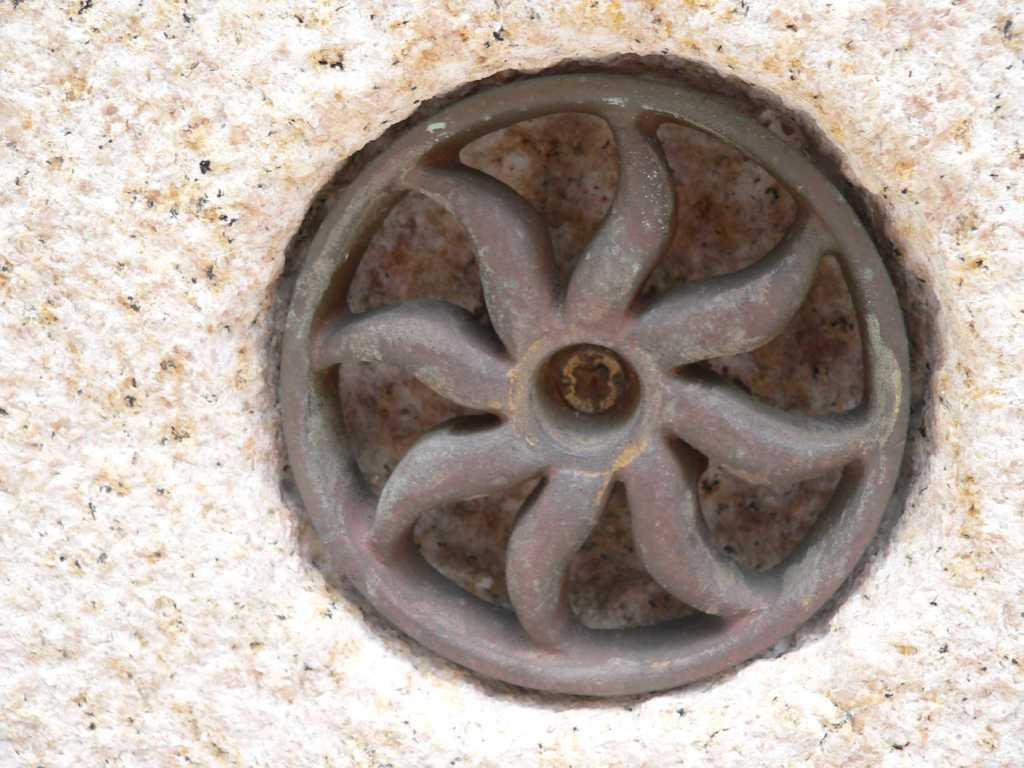What is the main object in the image? There is a wheel in the image. Where is the wheel located? The wheel is in a wall. Can you describe the color of the wall? The wall has a lite pink and brown color. What type of jam is being served on the wheel in the image? There is no jam or any food item present in the image; it only features a wheel in a wall with a lite pink and brown color. 